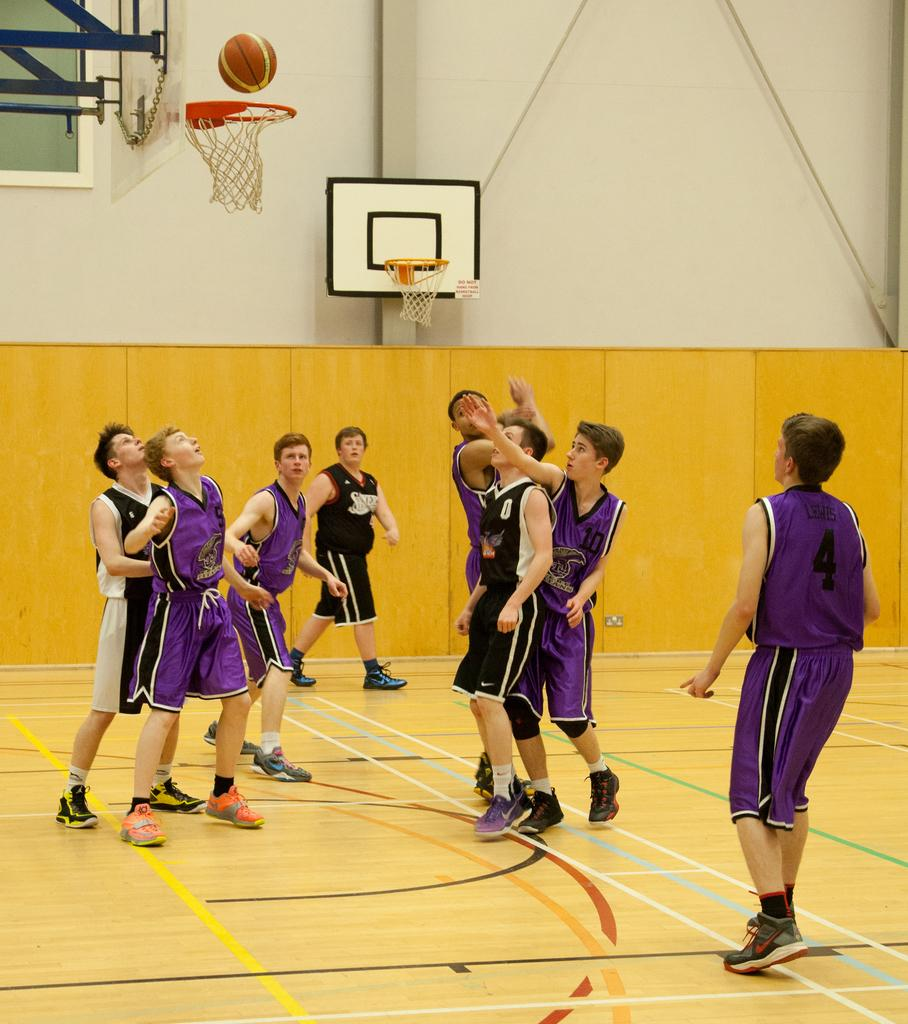Who or what is present in the image? There are people in the image. What activity are the people engaged in? The basketball hoops in the image suggest that the people are playing basketball. What is happening with the ball in the image? A ball is in the air in the image. What can be seen beneath the people's feet in the image? The floor is visible in the image. What is visible behind the people in the image? There is a wall in the background of the image. What is the amount of transport visible in the image? There is no transport visible in the image; it features people playing basketball. What sense is being utilized by the people in the image? The question is unanswerable based on the provided facts, as it does not specify which sense is being referred to. 